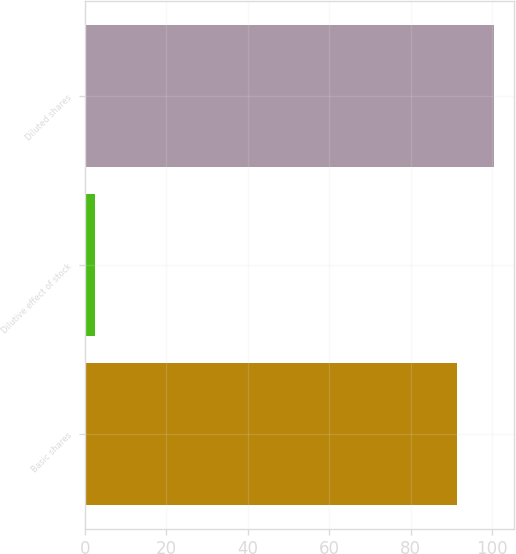Convert chart to OTSL. <chart><loc_0><loc_0><loc_500><loc_500><bar_chart><fcel>Basic shares<fcel>Dilutive effect of stock<fcel>Diluted shares<nl><fcel>91.3<fcel>2.4<fcel>100.43<nl></chart> 